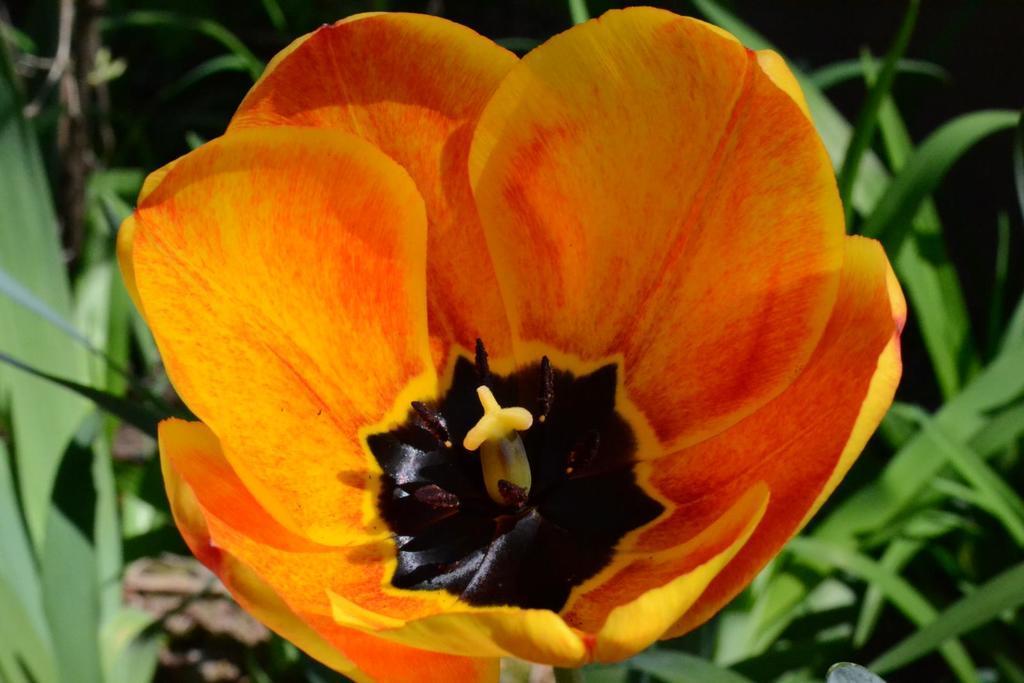Please provide a concise description of this image. In this picture there is a flower which is yellow in color in the center of the image and there are plants around the area of the image, there are other plants around the area of the image. 